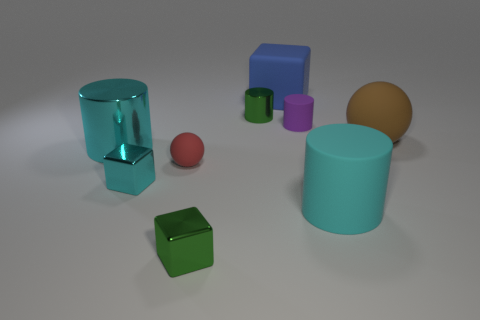Subtract all green metal cylinders. How many cylinders are left? 3 Subtract all green balls. How many cyan cylinders are left? 2 Subtract all purple cylinders. How many cylinders are left? 3 Subtract 2 cylinders. How many cylinders are left? 2 Subtract all brown cylinders. Subtract all yellow blocks. How many cylinders are left? 4 Subtract all cylinders. How many objects are left? 5 Subtract 0 yellow cylinders. How many objects are left? 9 Subtract all tiny cubes. Subtract all brown rubber objects. How many objects are left? 6 Add 8 small red matte balls. How many small red matte balls are left? 9 Add 1 cyan shiny cubes. How many cyan shiny cubes exist? 2 